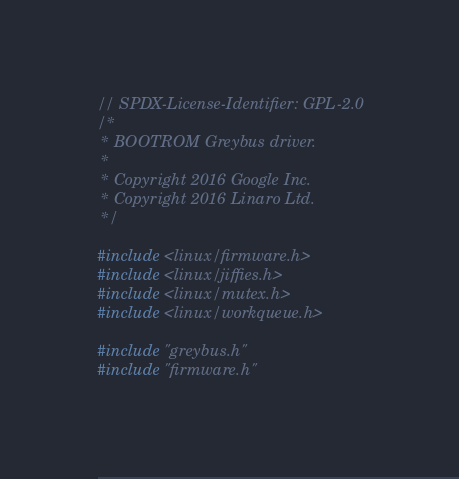<code> <loc_0><loc_0><loc_500><loc_500><_C_>// SPDX-License-Identifier: GPL-2.0
/*
 * BOOTROM Greybus driver.
 *
 * Copyright 2016 Google Inc.
 * Copyright 2016 Linaro Ltd.
 */

#include <linux/firmware.h>
#include <linux/jiffies.h>
#include <linux/mutex.h>
#include <linux/workqueue.h>

#include "greybus.h"
#include "firmware.h"
</code> 